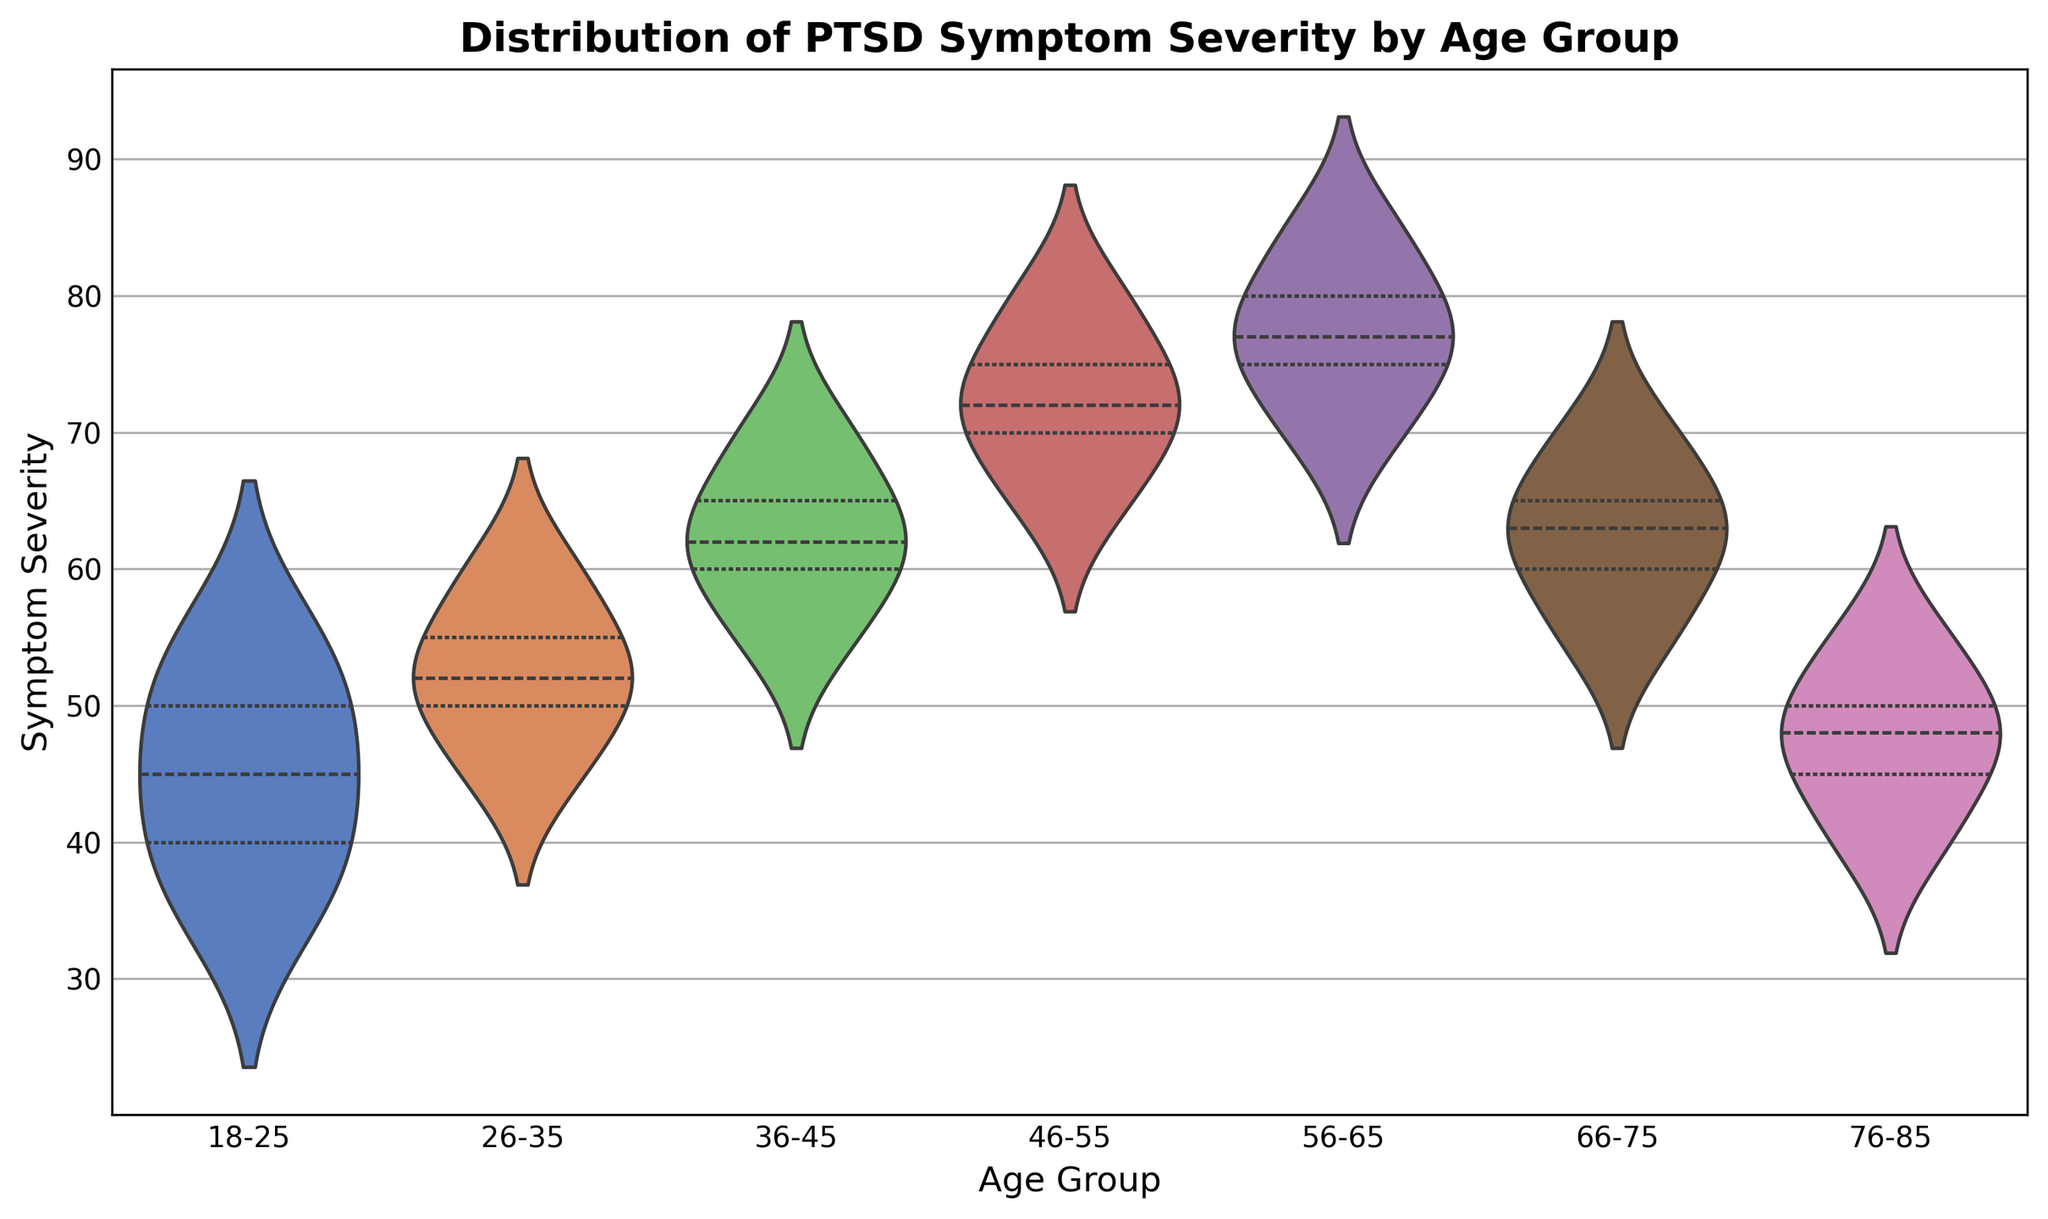What's the median severity of PTSD symptoms in the age group 36-45? The median is the middle value of a data set when ordered. In the age group 36-45, the values are [55, 60, 62, 65, 70]. The middle value is 62.
Answer: 62 Which age group has the lowest median PTSD symptom severity? Review the medians of each violin plot: 
- 18-25: Median at approximately 45
- 26-35: Median at approximately 52
- 36-45: Median at approximately 62
- 46-55: Median at approximately 72
- 56-65: Median at approximately 77
- 66-75: Median at approximately 63
- 76-85: Median at approximately 48
The age group 18-25 has the lowest median.
Answer: 18-25 Which age group has the most spread in the PTSD symptom severity? The spread can be seen by the width and length of the violin plot. The age group 56-65 has a wide and tall range indicating higher spread.
Answer: 56-65 How does the median symptom severity of the age group 46-55 compare to that of 26-35? The median for 46-55 is approximately 72, while for 26-35 it is approximately 52, indicating the median for 46-55 is higher.
Answer: Higher What is the interquartile range (IQR) of symptom severity for the age group 56-65? The IQR is the range between the upper quartile (75th percentile) and the lower quartile (25th percentile). The values for 56-65:
- Upper quartile (approximately 82.5)
- Lower quartile (approximately 72.5)
So, IQR = 82.5 - 72.5 = 10.
Answer: 10 Which age group has the smallest interquartile range of PTSD symptom severity? Assess the IQR by looking at the width of the violin plot. The age group 76-85 has the smallest IQR, indicating a tight distribution around the median.
Answer: 76-85 Is the median PTSD symptom severity for the age group 66-75 closer to the upper or lower end of the range for that group? The median for 66-75 is around 63, closer to the lower end of the range (55 to 70).
Answer: Lower end 